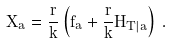<formula> <loc_0><loc_0><loc_500><loc_500>X _ { a } = \frac { r } { k } \left ( f _ { a } + \frac { r } { k } H _ { T | a } \right ) \, .</formula> 